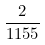<formula> <loc_0><loc_0><loc_500><loc_500>\frac { 2 } { 1 1 5 5 }</formula> 